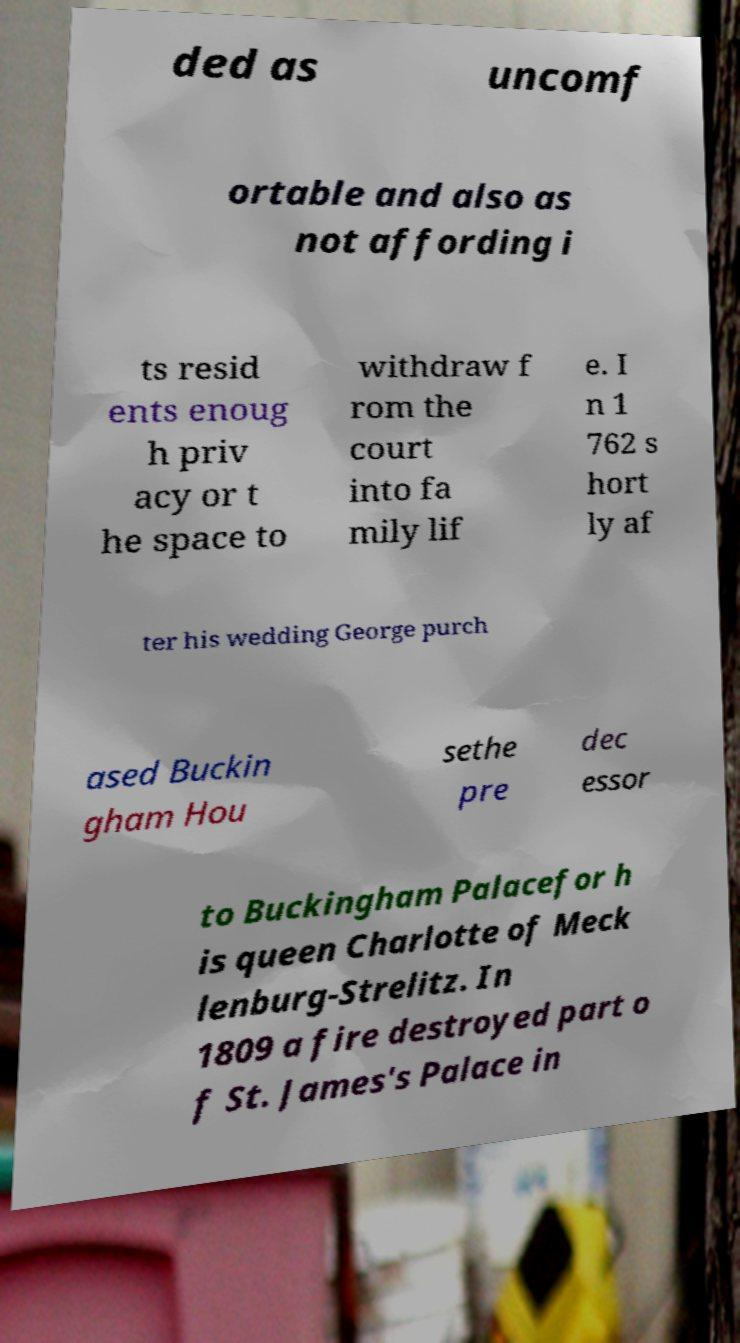There's text embedded in this image that I need extracted. Can you transcribe it verbatim? ded as uncomf ortable and also as not affording i ts resid ents enoug h priv acy or t he space to withdraw f rom the court into fa mily lif e. I n 1 762 s hort ly af ter his wedding George purch ased Buckin gham Hou sethe pre dec essor to Buckingham Palacefor h is queen Charlotte of Meck lenburg-Strelitz. In 1809 a fire destroyed part o f St. James's Palace in 